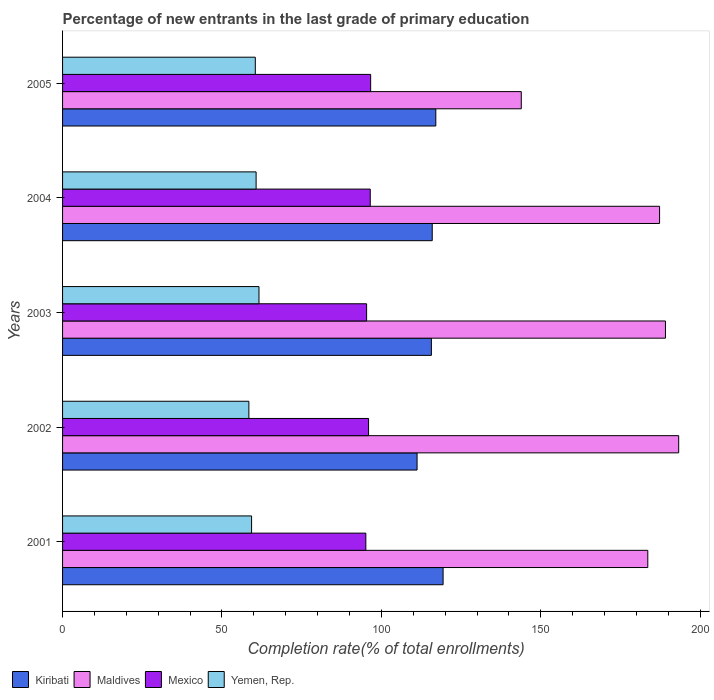Are the number of bars on each tick of the Y-axis equal?
Offer a very short reply. Yes. What is the label of the 3rd group of bars from the top?
Provide a succinct answer. 2003. In how many cases, is the number of bars for a given year not equal to the number of legend labels?
Keep it short and to the point. 0. What is the percentage of new entrants in Maldives in 2005?
Offer a very short reply. 143.89. Across all years, what is the maximum percentage of new entrants in Mexico?
Keep it short and to the point. 96.64. Across all years, what is the minimum percentage of new entrants in Mexico?
Offer a terse response. 95.13. What is the total percentage of new entrants in Yemen, Rep. in the graph?
Offer a terse response. 300.51. What is the difference between the percentage of new entrants in Kiribati in 2001 and that in 2004?
Your answer should be compact. 3.41. What is the difference between the percentage of new entrants in Mexico in 2005 and the percentage of new entrants in Kiribati in 2002?
Make the answer very short. -14.56. What is the average percentage of new entrants in Kiribati per year?
Your response must be concise. 115.86. In the year 2005, what is the difference between the percentage of new entrants in Maldives and percentage of new entrants in Kiribati?
Make the answer very short. 26.81. In how many years, is the percentage of new entrants in Mexico greater than 150 %?
Keep it short and to the point. 0. What is the ratio of the percentage of new entrants in Mexico in 2003 to that in 2005?
Your answer should be compact. 0.99. Is the percentage of new entrants in Yemen, Rep. in 2001 less than that in 2005?
Your answer should be compact. Yes. What is the difference between the highest and the second highest percentage of new entrants in Maldives?
Your answer should be compact. 4.15. What is the difference between the highest and the lowest percentage of new entrants in Maldives?
Your answer should be very brief. 49.38. In how many years, is the percentage of new entrants in Yemen, Rep. greater than the average percentage of new entrants in Yemen, Rep. taken over all years?
Give a very brief answer. 3. Is it the case that in every year, the sum of the percentage of new entrants in Yemen, Rep. and percentage of new entrants in Kiribati is greater than the sum of percentage of new entrants in Maldives and percentage of new entrants in Mexico?
Your answer should be compact. No. What does the 2nd bar from the bottom in 2003 represents?
Make the answer very short. Maldives. Is it the case that in every year, the sum of the percentage of new entrants in Mexico and percentage of new entrants in Maldives is greater than the percentage of new entrants in Yemen, Rep.?
Make the answer very short. Yes. How many bars are there?
Offer a very short reply. 20. Are all the bars in the graph horizontal?
Provide a succinct answer. Yes. Are the values on the major ticks of X-axis written in scientific E-notation?
Ensure brevity in your answer.  No. What is the title of the graph?
Provide a short and direct response. Percentage of new entrants in the last grade of primary education. Does "Uganda" appear as one of the legend labels in the graph?
Ensure brevity in your answer.  No. What is the label or title of the X-axis?
Provide a succinct answer. Completion rate(% of total enrollments). What is the label or title of the Y-axis?
Give a very brief answer. Years. What is the Completion rate(% of total enrollments) of Kiribati in 2001?
Ensure brevity in your answer.  119.36. What is the Completion rate(% of total enrollments) in Maldives in 2001?
Your answer should be very brief. 183.57. What is the Completion rate(% of total enrollments) of Mexico in 2001?
Offer a terse response. 95.13. What is the Completion rate(% of total enrollments) in Yemen, Rep. in 2001?
Keep it short and to the point. 59.29. What is the Completion rate(% of total enrollments) in Kiribati in 2002?
Make the answer very short. 111.2. What is the Completion rate(% of total enrollments) of Maldives in 2002?
Your response must be concise. 193.26. What is the Completion rate(% of total enrollments) in Mexico in 2002?
Offer a terse response. 95.98. What is the Completion rate(% of total enrollments) in Yemen, Rep. in 2002?
Give a very brief answer. 58.44. What is the Completion rate(% of total enrollments) in Kiribati in 2003?
Ensure brevity in your answer.  115.69. What is the Completion rate(% of total enrollments) of Maldives in 2003?
Provide a short and direct response. 189.12. What is the Completion rate(% of total enrollments) of Mexico in 2003?
Offer a terse response. 95.37. What is the Completion rate(% of total enrollments) of Yemen, Rep. in 2003?
Make the answer very short. 61.61. What is the Completion rate(% of total enrollments) in Kiribati in 2004?
Your answer should be compact. 115.96. What is the Completion rate(% of total enrollments) of Maldives in 2004?
Provide a succinct answer. 187.27. What is the Completion rate(% of total enrollments) of Mexico in 2004?
Offer a terse response. 96.51. What is the Completion rate(% of total enrollments) of Yemen, Rep. in 2004?
Offer a terse response. 60.71. What is the Completion rate(% of total enrollments) in Kiribati in 2005?
Provide a short and direct response. 117.08. What is the Completion rate(% of total enrollments) of Maldives in 2005?
Your response must be concise. 143.89. What is the Completion rate(% of total enrollments) of Mexico in 2005?
Your response must be concise. 96.64. What is the Completion rate(% of total enrollments) in Yemen, Rep. in 2005?
Provide a succinct answer. 60.46. Across all years, what is the maximum Completion rate(% of total enrollments) of Kiribati?
Make the answer very short. 119.36. Across all years, what is the maximum Completion rate(% of total enrollments) in Maldives?
Provide a succinct answer. 193.26. Across all years, what is the maximum Completion rate(% of total enrollments) in Mexico?
Offer a very short reply. 96.64. Across all years, what is the maximum Completion rate(% of total enrollments) in Yemen, Rep.?
Your answer should be compact. 61.61. Across all years, what is the minimum Completion rate(% of total enrollments) in Kiribati?
Offer a very short reply. 111.2. Across all years, what is the minimum Completion rate(% of total enrollments) in Maldives?
Offer a very short reply. 143.89. Across all years, what is the minimum Completion rate(% of total enrollments) of Mexico?
Provide a succinct answer. 95.13. Across all years, what is the minimum Completion rate(% of total enrollments) in Yemen, Rep.?
Offer a terse response. 58.44. What is the total Completion rate(% of total enrollments) of Kiribati in the graph?
Offer a terse response. 579.29. What is the total Completion rate(% of total enrollments) in Maldives in the graph?
Provide a succinct answer. 897.11. What is the total Completion rate(% of total enrollments) of Mexico in the graph?
Keep it short and to the point. 479.64. What is the total Completion rate(% of total enrollments) of Yemen, Rep. in the graph?
Your answer should be compact. 300.51. What is the difference between the Completion rate(% of total enrollments) in Kiribati in 2001 and that in 2002?
Provide a short and direct response. 8.16. What is the difference between the Completion rate(% of total enrollments) in Maldives in 2001 and that in 2002?
Ensure brevity in your answer.  -9.69. What is the difference between the Completion rate(% of total enrollments) of Mexico in 2001 and that in 2002?
Your response must be concise. -0.85. What is the difference between the Completion rate(% of total enrollments) of Yemen, Rep. in 2001 and that in 2002?
Provide a short and direct response. 0.85. What is the difference between the Completion rate(% of total enrollments) in Kiribati in 2001 and that in 2003?
Keep it short and to the point. 3.67. What is the difference between the Completion rate(% of total enrollments) of Maldives in 2001 and that in 2003?
Provide a succinct answer. -5.54. What is the difference between the Completion rate(% of total enrollments) of Mexico in 2001 and that in 2003?
Offer a very short reply. -0.24. What is the difference between the Completion rate(% of total enrollments) of Yemen, Rep. in 2001 and that in 2003?
Give a very brief answer. -2.33. What is the difference between the Completion rate(% of total enrollments) in Kiribati in 2001 and that in 2004?
Provide a short and direct response. 3.41. What is the difference between the Completion rate(% of total enrollments) in Maldives in 2001 and that in 2004?
Provide a short and direct response. -3.69. What is the difference between the Completion rate(% of total enrollments) in Mexico in 2001 and that in 2004?
Offer a very short reply. -1.38. What is the difference between the Completion rate(% of total enrollments) in Yemen, Rep. in 2001 and that in 2004?
Offer a very short reply. -1.42. What is the difference between the Completion rate(% of total enrollments) of Kiribati in 2001 and that in 2005?
Make the answer very short. 2.28. What is the difference between the Completion rate(% of total enrollments) in Maldives in 2001 and that in 2005?
Offer a terse response. 39.69. What is the difference between the Completion rate(% of total enrollments) of Mexico in 2001 and that in 2005?
Make the answer very short. -1.51. What is the difference between the Completion rate(% of total enrollments) of Yemen, Rep. in 2001 and that in 2005?
Your answer should be compact. -1.17. What is the difference between the Completion rate(% of total enrollments) of Kiribati in 2002 and that in 2003?
Make the answer very short. -4.49. What is the difference between the Completion rate(% of total enrollments) of Maldives in 2002 and that in 2003?
Give a very brief answer. 4.15. What is the difference between the Completion rate(% of total enrollments) of Mexico in 2002 and that in 2003?
Provide a succinct answer. 0.61. What is the difference between the Completion rate(% of total enrollments) of Yemen, Rep. in 2002 and that in 2003?
Offer a very short reply. -3.17. What is the difference between the Completion rate(% of total enrollments) of Kiribati in 2002 and that in 2004?
Your answer should be compact. -4.75. What is the difference between the Completion rate(% of total enrollments) in Maldives in 2002 and that in 2004?
Make the answer very short. 5.99. What is the difference between the Completion rate(% of total enrollments) of Mexico in 2002 and that in 2004?
Your response must be concise. -0.53. What is the difference between the Completion rate(% of total enrollments) of Yemen, Rep. in 2002 and that in 2004?
Your response must be concise. -2.27. What is the difference between the Completion rate(% of total enrollments) of Kiribati in 2002 and that in 2005?
Provide a succinct answer. -5.87. What is the difference between the Completion rate(% of total enrollments) of Maldives in 2002 and that in 2005?
Make the answer very short. 49.38. What is the difference between the Completion rate(% of total enrollments) of Mexico in 2002 and that in 2005?
Your answer should be very brief. -0.66. What is the difference between the Completion rate(% of total enrollments) of Yemen, Rep. in 2002 and that in 2005?
Keep it short and to the point. -2.02. What is the difference between the Completion rate(% of total enrollments) of Kiribati in 2003 and that in 2004?
Ensure brevity in your answer.  -0.27. What is the difference between the Completion rate(% of total enrollments) of Maldives in 2003 and that in 2004?
Make the answer very short. 1.85. What is the difference between the Completion rate(% of total enrollments) in Mexico in 2003 and that in 2004?
Your answer should be compact. -1.14. What is the difference between the Completion rate(% of total enrollments) of Yemen, Rep. in 2003 and that in 2004?
Provide a succinct answer. 0.9. What is the difference between the Completion rate(% of total enrollments) of Kiribati in 2003 and that in 2005?
Give a very brief answer. -1.39. What is the difference between the Completion rate(% of total enrollments) of Maldives in 2003 and that in 2005?
Make the answer very short. 45.23. What is the difference between the Completion rate(% of total enrollments) in Mexico in 2003 and that in 2005?
Provide a succinct answer. -1.27. What is the difference between the Completion rate(% of total enrollments) of Yemen, Rep. in 2003 and that in 2005?
Ensure brevity in your answer.  1.15. What is the difference between the Completion rate(% of total enrollments) of Kiribati in 2004 and that in 2005?
Provide a short and direct response. -1.12. What is the difference between the Completion rate(% of total enrollments) of Maldives in 2004 and that in 2005?
Provide a short and direct response. 43.38. What is the difference between the Completion rate(% of total enrollments) of Mexico in 2004 and that in 2005?
Ensure brevity in your answer.  -0.12. What is the difference between the Completion rate(% of total enrollments) in Yemen, Rep. in 2004 and that in 2005?
Your response must be concise. 0.25. What is the difference between the Completion rate(% of total enrollments) of Kiribati in 2001 and the Completion rate(% of total enrollments) of Maldives in 2002?
Provide a succinct answer. -73.9. What is the difference between the Completion rate(% of total enrollments) of Kiribati in 2001 and the Completion rate(% of total enrollments) of Mexico in 2002?
Offer a very short reply. 23.38. What is the difference between the Completion rate(% of total enrollments) in Kiribati in 2001 and the Completion rate(% of total enrollments) in Yemen, Rep. in 2002?
Provide a short and direct response. 60.92. What is the difference between the Completion rate(% of total enrollments) of Maldives in 2001 and the Completion rate(% of total enrollments) of Mexico in 2002?
Keep it short and to the point. 87.59. What is the difference between the Completion rate(% of total enrollments) of Maldives in 2001 and the Completion rate(% of total enrollments) of Yemen, Rep. in 2002?
Provide a short and direct response. 125.13. What is the difference between the Completion rate(% of total enrollments) of Mexico in 2001 and the Completion rate(% of total enrollments) of Yemen, Rep. in 2002?
Your response must be concise. 36.69. What is the difference between the Completion rate(% of total enrollments) of Kiribati in 2001 and the Completion rate(% of total enrollments) of Maldives in 2003?
Your answer should be compact. -69.76. What is the difference between the Completion rate(% of total enrollments) in Kiribati in 2001 and the Completion rate(% of total enrollments) in Mexico in 2003?
Offer a terse response. 23.99. What is the difference between the Completion rate(% of total enrollments) of Kiribati in 2001 and the Completion rate(% of total enrollments) of Yemen, Rep. in 2003?
Give a very brief answer. 57.75. What is the difference between the Completion rate(% of total enrollments) of Maldives in 2001 and the Completion rate(% of total enrollments) of Mexico in 2003?
Offer a very short reply. 88.2. What is the difference between the Completion rate(% of total enrollments) in Maldives in 2001 and the Completion rate(% of total enrollments) in Yemen, Rep. in 2003?
Offer a very short reply. 121.96. What is the difference between the Completion rate(% of total enrollments) of Mexico in 2001 and the Completion rate(% of total enrollments) of Yemen, Rep. in 2003?
Provide a succinct answer. 33.52. What is the difference between the Completion rate(% of total enrollments) in Kiribati in 2001 and the Completion rate(% of total enrollments) in Maldives in 2004?
Offer a very short reply. -67.91. What is the difference between the Completion rate(% of total enrollments) of Kiribati in 2001 and the Completion rate(% of total enrollments) of Mexico in 2004?
Ensure brevity in your answer.  22.85. What is the difference between the Completion rate(% of total enrollments) in Kiribati in 2001 and the Completion rate(% of total enrollments) in Yemen, Rep. in 2004?
Ensure brevity in your answer.  58.65. What is the difference between the Completion rate(% of total enrollments) in Maldives in 2001 and the Completion rate(% of total enrollments) in Mexico in 2004?
Give a very brief answer. 87.06. What is the difference between the Completion rate(% of total enrollments) in Maldives in 2001 and the Completion rate(% of total enrollments) in Yemen, Rep. in 2004?
Give a very brief answer. 122.86. What is the difference between the Completion rate(% of total enrollments) of Mexico in 2001 and the Completion rate(% of total enrollments) of Yemen, Rep. in 2004?
Your response must be concise. 34.42. What is the difference between the Completion rate(% of total enrollments) in Kiribati in 2001 and the Completion rate(% of total enrollments) in Maldives in 2005?
Offer a terse response. -24.53. What is the difference between the Completion rate(% of total enrollments) of Kiribati in 2001 and the Completion rate(% of total enrollments) of Mexico in 2005?
Your response must be concise. 22.72. What is the difference between the Completion rate(% of total enrollments) in Kiribati in 2001 and the Completion rate(% of total enrollments) in Yemen, Rep. in 2005?
Keep it short and to the point. 58.9. What is the difference between the Completion rate(% of total enrollments) of Maldives in 2001 and the Completion rate(% of total enrollments) of Mexico in 2005?
Provide a succinct answer. 86.93. What is the difference between the Completion rate(% of total enrollments) of Maldives in 2001 and the Completion rate(% of total enrollments) of Yemen, Rep. in 2005?
Offer a terse response. 123.11. What is the difference between the Completion rate(% of total enrollments) in Mexico in 2001 and the Completion rate(% of total enrollments) in Yemen, Rep. in 2005?
Offer a very short reply. 34.67. What is the difference between the Completion rate(% of total enrollments) of Kiribati in 2002 and the Completion rate(% of total enrollments) of Maldives in 2003?
Keep it short and to the point. -77.92. What is the difference between the Completion rate(% of total enrollments) in Kiribati in 2002 and the Completion rate(% of total enrollments) in Mexico in 2003?
Provide a succinct answer. 15.83. What is the difference between the Completion rate(% of total enrollments) in Kiribati in 2002 and the Completion rate(% of total enrollments) in Yemen, Rep. in 2003?
Provide a short and direct response. 49.59. What is the difference between the Completion rate(% of total enrollments) of Maldives in 2002 and the Completion rate(% of total enrollments) of Mexico in 2003?
Your answer should be compact. 97.89. What is the difference between the Completion rate(% of total enrollments) in Maldives in 2002 and the Completion rate(% of total enrollments) in Yemen, Rep. in 2003?
Keep it short and to the point. 131.65. What is the difference between the Completion rate(% of total enrollments) of Mexico in 2002 and the Completion rate(% of total enrollments) of Yemen, Rep. in 2003?
Offer a very short reply. 34.37. What is the difference between the Completion rate(% of total enrollments) in Kiribati in 2002 and the Completion rate(% of total enrollments) in Maldives in 2004?
Provide a short and direct response. -76.07. What is the difference between the Completion rate(% of total enrollments) in Kiribati in 2002 and the Completion rate(% of total enrollments) in Mexico in 2004?
Your answer should be compact. 14.69. What is the difference between the Completion rate(% of total enrollments) of Kiribati in 2002 and the Completion rate(% of total enrollments) of Yemen, Rep. in 2004?
Keep it short and to the point. 50.49. What is the difference between the Completion rate(% of total enrollments) in Maldives in 2002 and the Completion rate(% of total enrollments) in Mexico in 2004?
Give a very brief answer. 96.75. What is the difference between the Completion rate(% of total enrollments) in Maldives in 2002 and the Completion rate(% of total enrollments) in Yemen, Rep. in 2004?
Make the answer very short. 132.55. What is the difference between the Completion rate(% of total enrollments) in Mexico in 2002 and the Completion rate(% of total enrollments) in Yemen, Rep. in 2004?
Offer a very short reply. 35.27. What is the difference between the Completion rate(% of total enrollments) in Kiribati in 2002 and the Completion rate(% of total enrollments) in Maldives in 2005?
Your answer should be very brief. -32.68. What is the difference between the Completion rate(% of total enrollments) of Kiribati in 2002 and the Completion rate(% of total enrollments) of Mexico in 2005?
Your answer should be compact. 14.56. What is the difference between the Completion rate(% of total enrollments) in Kiribati in 2002 and the Completion rate(% of total enrollments) in Yemen, Rep. in 2005?
Provide a succinct answer. 50.74. What is the difference between the Completion rate(% of total enrollments) of Maldives in 2002 and the Completion rate(% of total enrollments) of Mexico in 2005?
Offer a very short reply. 96.62. What is the difference between the Completion rate(% of total enrollments) of Maldives in 2002 and the Completion rate(% of total enrollments) of Yemen, Rep. in 2005?
Keep it short and to the point. 132.8. What is the difference between the Completion rate(% of total enrollments) of Mexico in 2002 and the Completion rate(% of total enrollments) of Yemen, Rep. in 2005?
Your answer should be very brief. 35.52. What is the difference between the Completion rate(% of total enrollments) in Kiribati in 2003 and the Completion rate(% of total enrollments) in Maldives in 2004?
Make the answer very short. -71.58. What is the difference between the Completion rate(% of total enrollments) of Kiribati in 2003 and the Completion rate(% of total enrollments) of Mexico in 2004?
Ensure brevity in your answer.  19.18. What is the difference between the Completion rate(% of total enrollments) in Kiribati in 2003 and the Completion rate(% of total enrollments) in Yemen, Rep. in 2004?
Offer a terse response. 54.98. What is the difference between the Completion rate(% of total enrollments) in Maldives in 2003 and the Completion rate(% of total enrollments) in Mexico in 2004?
Provide a succinct answer. 92.6. What is the difference between the Completion rate(% of total enrollments) of Maldives in 2003 and the Completion rate(% of total enrollments) of Yemen, Rep. in 2004?
Your response must be concise. 128.41. What is the difference between the Completion rate(% of total enrollments) of Mexico in 2003 and the Completion rate(% of total enrollments) of Yemen, Rep. in 2004?
Offer a very short reply. 34.66. What is the difference between the Completion rate(% of total enrollments) in Kiribati in 2003 and the Completion rate(% of total enrollments) in Maldives in 2005?
Ensure brevity in your answer.  -28.2. What is the difference between the Completion rate(% of total enrollments) of Kiribati in 2003 and the Completion rate(% of total enrollments) of Mexico in 2005?
Your answer should be very brief. 19.05. What is the difference between the Completion rate(% of total enrollments) in Kiribati in 2003 and the Completion rate(% of total enrollments) in Yemen, Rep. in 2005?
Your answer should be very brief. 55.23. What is the difference between the Completion rate(% of total enrollments) of Maldives in 2003 and the Completion rate(% of total enrollments) of Mexico in 2005?
Ensure brevity in your answer.  92.48. What is the difference between the Completion rate(% of total enrollments) of Maldives in 2003 and the Completion rate(% of total enrollments) of Yemen, Rep. in 2005?
Offer a terse response. 128.66. What is the difference between the Completion rate(% of total enrollments) of Mexico in 2003 and the Completion rate(% of total enrollments) of Yemen, Rep. in 2005?
Offer a terse response. 34.91. What is the difference between the Completion rate(% of total enrollments) of Kiribati in 2004 and the Completion rate(% of total enrollments) of Maldives in 2005?
Give a very brief answer. -27.93. What is the difference between the Completion rate(% of total enrollments) in Kiribati in 2004 and the Completion rate(% of total enrollments) in Mexico in 2005?
Your answer should be very brief. 19.32. What is the difference between the Completion rate(% of total enrollments) in Kiribati in 2004 and the Completion rate(% of total enrollments) in Yemen, Rep. in 2005?
Offer a very short reply. 55.49. What is the difference between the Completion rate(% of total enrollments) in Maldives in 2004 and the Completion rate(% of total enrollments) in Mexico in 2005?
Keep it short and to the point. 90.63. What is the difference between the Completion rate(% of total enrollments) in Maldives in 2004 and the Completion rate(% of total enrollments) in Yemen, Rep. in 2005?
Keep it short and to the point. 126.81. What is the difference between the Completion rate(% of total enrollments) in Mexico in 2004 and the Completion rate(% of total enrollments) in Yemen, Rep. in 2005?
Offer a very short reply. 36.05. What is the average Completion rate(% of total enrollments) of Kiribati per year?
Your response must be concise. 115.86. What is the average Completion rate(% of total enrollments) in Maldives per year?
Your response must be concise. 179.42. What is the average Completion rate(% of total enrollments) in Mexico per year?
Give a very brief answer. 95.93. What is the average Completion rate(% of total enrollments) in Yemen, Rep. per year?
Your answer should be compact. 60.1. In the year 2001, what is the difference between the Completion rate(% of total enrollments) in Kiribati and Completion rate(% of total enrollments) in Maldives?
Provide a succinct answer. -64.21. In the year 2001, what is the difference between the Completion rate(% of total enrollments) in Kiribati and Completion rate(% of total enrollments) in Mexico?
Provide a succinct answer. 24.23. In the year 2001, what is the difference between the Completion rate(% of total enrollments) of Kiribati and Completion rate(% of total enrollments) of Yemen, Rep.?
Offer a terse response. 60.07. In the year 2001, what is the difference between the Completion rate(% of total enrollments) of Maldives and Completion rate(% of total enrollments) of Mexico?
Give a very brief answer. 88.44. In the year 2001, what is the difference between the Completion rate(% of total enrollments) of Maldives and Completion rate(% of total enrollments) of Yemen, Rep.?
Give a very brief answer. 124.29. In the year 2001, what is the difference between the Completion rate(% of total enrollments) in Mexico and Completion rate(% of total enrollments) in Yemen, Rep.?
Offer a very short reply. 35.84. In the year 2002, what is the difference between the Completion rate(% of total enrollments) of Kiribati and Completion rate(% of total enrollments) of Maldives?
Ensure brevity in your answer.  -82.06. In the year 2002, what is the difference between the Completion rate(% of total enrollments) of Kiribati and Completion rate(% of total enrollments) of Mexico?
Your answer should be compact. 15.22. In the year 2002, what is the difference between the Completion rate(% of total enrollments) of Kiribati and Completion rate(% of total enrollments) of Yemen, Rep.?
Your response must be concise. 52.76. In the year 2002, what is the difference between the Completion rate(% of total enrollments) in Maldives and Completion rate(% of total enrollments) in Mexico?
Offer a very short reply. 97.28. In the year 2002, what is the difference between the Completion rate(% of total enrollments) in Maldives and Completion rate(% of total enrollments) in Yemen, Rep.?
Provide a succinct answer. 134.82. In the year 2002, what is the difference between the Completion rate(% of total enrollments) of Mexico and Completion rate(% of total enrollments) of Yemen, Rep.?
Your response must be concise. 37.54. In the year 2003, what is the difference between the Completion rate(% of total enrollments) in Kiribati and Completion rate(% of total enrollments) in Maldives?
Offer a very short reply. -73.43. In the year 2003, what is the difference between the Completion rate(% of total enrollments) of Kiribati and Completion rate(% of total enrollments) of Mexico?
Keep it short and to the point. 20.32. In the year 2003, what is the difference between the Completion rate(% of total enrollments) of Kiribati and Completion rate(% of total enrollments) of Yemen, Rep.?
Make the answer very short. 54.08. In the year 2003, what is the difference between the Completion rate(% of total enrollments) of Maldives and Completion rate(% of total enrollments) of Mexico?
Your answer should be very brief. 93.75. In the year 2003, what is the difference between the Completion rate(% of total enrollments) in Maldives and Completion rate(% of total enrollments) in Yemen, Rep.?
Keep it short and to the point. 127.51. In the year 2003, what is the difference between the Completion rate(% of total enrollments) in Mexico and Completion rate(% of total enrollments) in Yemen, Rep.?
Offer a terse response. 33.76. In the year 2004, what is the difference between the Completion rate(% of total enrollments) in Kiribati and Completion rate(% of total enrollments) in Maldives?
Provide a short and direct response. -71.31. In the year 2004, what is the difference between the Completion rate(% of total enrollments) of Kiribati and Completion rate(% of total enrollments) of Mexico?
Give a very brief answer. 19.44. In the year 2004, what is the difference between the Completion rate(% of total enrollments) of Kiribati and Completion rate(% of total enrollments) of Yemen, Rep.?
Keep it short and to the point. 55.25. In the year 2004, what is the difference between the Completion rate(% of total enrollments) in Maldives and Completion rate(% of total enrollments) in Mexico?
Keep it short and to the point. 90.75. In the year 2004, what is the difference between the Completion rate(% of total enrollments) in Maldives and Completion rate(% of total enrollments) in Yemen, Rep.?
Ensure brevity in your answer.  126.56. In the year 2004, what is the difference between the Completion rate(% of total enrollments) of Mexico and Completion rate(% of total enrollments) of Yemen, Rep.?
Give a very brief answer. 35.8. In the year 2005, what is the difference between the Completion rate(% of total enrollments) of Kiribati and Completion rate(% of total enrollments) of Maldives?
Provide a short and direct response. -26.81. In the year 2005, what is the difference between the Completion rate(% of total enrollments) of Kiribati and Completion rate(% of total enrollments) of Mexico?
Give a very brief answer. 20.44. In the year 2005, what is the difference between the Completion rate(% of total enrollments) in Kiribati and Completion rate(% of total enrollments) in Yemen, Rep.?
Your answer should be compact. 56.62. In the year 2005, what is the difference between the Completion rate(% of total enrollments) of Maldives and Completion rate(% of total enrollments) of Mexico?
Keep it short and to the point. 47.25. In the year 2005, what is the difference between the Completion rate(% of total enrollments) of Maldives and Completion rate(% of total enrollments) of Yemen, Rep.?
Provide a short and direct response. 83.43. In the year 2005, what is the difference between the Completion rate(% of total enrollments) of Mexico and Completion rate(% of total enrollments) of Yemen, Rep.?
Your answer should be very brief. 36.18. What is the ratio of the Completion rate(% of total enrollments) in Kiribati in 2001 to that in 2002?
Provide a short and direct response. 1.07. What is the ratio of the Completion rate(% of total enrollments) in Maldives in 2001 to that in 2002?
Keep it short and to the point. 0.95. What is the ratio of the Completion rate(% of total enrollments) in Yemen, Rep. in 2001 to that in 2002?
Make the answer very short. 1.01. What is the ratio of the Completion rate(% of total enrollments) in Kiribati in 2001 to that in 2003?
Provide a succinct answer. 1.03. What is the ratio of the Completion rate(% of total enrollments) in Maldives in 2001 to that in 2003?
Provide a succinct answer. 0.97. What is the ratio of the Completion rate(% of total enrollments) of Mexico in 2001 to that in 2003?
Provide a succinct answer. 1. What is the ratio of the Completion rate(% of total enrollments) of Yemen, Rep. in 2001 to that in 2003?
Make the answer very short. 0.96. What is the ratio of the Completion rate(% of total enrollments) in Kiribati in 2001 to that in 2004?
Your answer should be very brief. 1.03. What is the ratio of the Completion rate(% of total enrollments) in Maldives in 2001 to that in 2004?
Offer a very short reply. 0.98. What is the ratio of the Completion rate(% of total enrollments) of Mexico in 2001 to that in 2004?
Your answer should be very brief. 0.99. What is the ratio of the Completion rate(% of total enrollments) of Yemen, Rep. in 2001 to that in 2004?
Your answer should be very brief. 0.98. What is the ratio of the Completion rate(% of total enrollments) in Kiribati in 2001 to that in 2005?
Keep it short and to the point. 1.02. What is the ratio of the Completion rate(% of total enrollments) of Maldives in 2001 to that in 2005?
Make the answer very short. 1.28. What is the ratio of the Completion rate(% of total enrollments) in Mexico in 2001 to that in 2005?
Make the answer very short. 0.98. What is the ratio of the Completion rate(% of total enrollments) in Yemen, Rep. in 2001 to that in 2005?
Your answer should be very brief. 0.98. What is the ratio of the Completion rate(% of total enrollments) of Kiribati in 2002 to that in 2003?
Provide a succinct answer. 0.96. What is the ratio of the Completion rate(% of total enrollments) in Maldives in 2002 to that in 2003?
Offer a very short reply. 1.02. What is the ratio of the Completion rate(% of total enrollments) of Mexico in 2002 to that in 2003?
Offer a very short reply. 1.01. What is the ratio of the Completion rate(% of total enrollments) in Yemen, Rep. in 2002 to that in 2003?
Provide a short and direct response. 0.95. What is the ratio of the Completion rate(% of total enrollments) in Maldives in 2002 to that in 2004?
Make the answer very short. 1.03. What is the ratio of the Completion rate(% of total enrollments) in Yemen, Rep. in 2002 to that in 2004?
Give a very brief answer. 0.96. What is the ratio of the Completion rate(% of total enrollments) in Kiribati in 2002 to that in 2005?
Provide a short and direct response. 0.95. What is the ratio of the Completion rate(% of total enrollments) of Maldives in 2002 to that in 2005?
Make the answer very short. 1.34. What is the ratio of the Completion rate(% of total enrollments) in Mexico in 2002 to that in 2005?
Provide a short and direct response. 0.99. What is the ratio of the Completion rate(% of total enrollments) in Yemen, Rep. in 2002 to that in 2005?
Offer a very short reply. 0.97. What is the ratio of the Completion rate(% of total enrollments) of Maldives in 2003 to that in 2004?
Ensure brevity in your answer.  1.01. What is the ratio of the Completion rate(% of total enrollments) in Mexico in 2003 to that in 2004?
Keep it short and to the point. 0.99. What is the ratio of the Completion rate(% of total enrollments) of Yemen, Rep. in 2003 to that in 2004?
Ensure brevity in your answer.  1.01. What is the ratio of the Completion rate(% of total enrollments) in Kiribati in 2003 to that in 2005?
Your answer should be compact. 0.99. What is the ratio of the Completion rate(% of total enrollments) of Maldives in 2003 to that in 2005?
Your answer should be compact. 1.31. What is the ratio of the Completion rate(% of total enrollments) in Mexico in 2003 to that in 2005?
Give a very brief answer. 0.99. What is the ratio of the Completion rate(% of total enrollments) of Yemen, Rep. in 2003 to that in 2005?
Give a very brief answer. 1.02. What is the ratio of the Completion rate(% of total enrollments) in Maldives in 2004 to that in 2005?
Give a very brief answer. 1.3. What is the ratio of the Completion rate(% of total enrollments) in Yemen, Rep. in 2004 to that in 2005?
Your answer should be very brief. 1. What is the difference between the highest and the second highest Completion rate(% of total enrollments) of Kiribati?
Make the answer very short. 2.28. What is the difference between the highest and the second highest Completion rate(% of total enrollments) in Maldives?
Provide a succinct answer. 4.15. What is the difference between the highest and the second highest Completion rate(% of total enrollments) of Yemen, Rep.?
Keep it short and to the point. 0.9. What is the difference between the highest and the lowest Completion rate(% of total enrollments) in Kiribati?
Your answer should be very brief. 8.16. What is the difference between the highest and the lowest Completion rate(% of total enrollments) of Maldives?
Offer a very short reply. 49.38. What is the difference between the highest and the lowest Completion rate(% of total enrollments) in Mexico?
Offer a terse response. 1.51. What is the difference between the highest and the lowest Completion rate(% of total enrollments) of Yemen, Rep.?
Your answer should be compact. 3.17. 